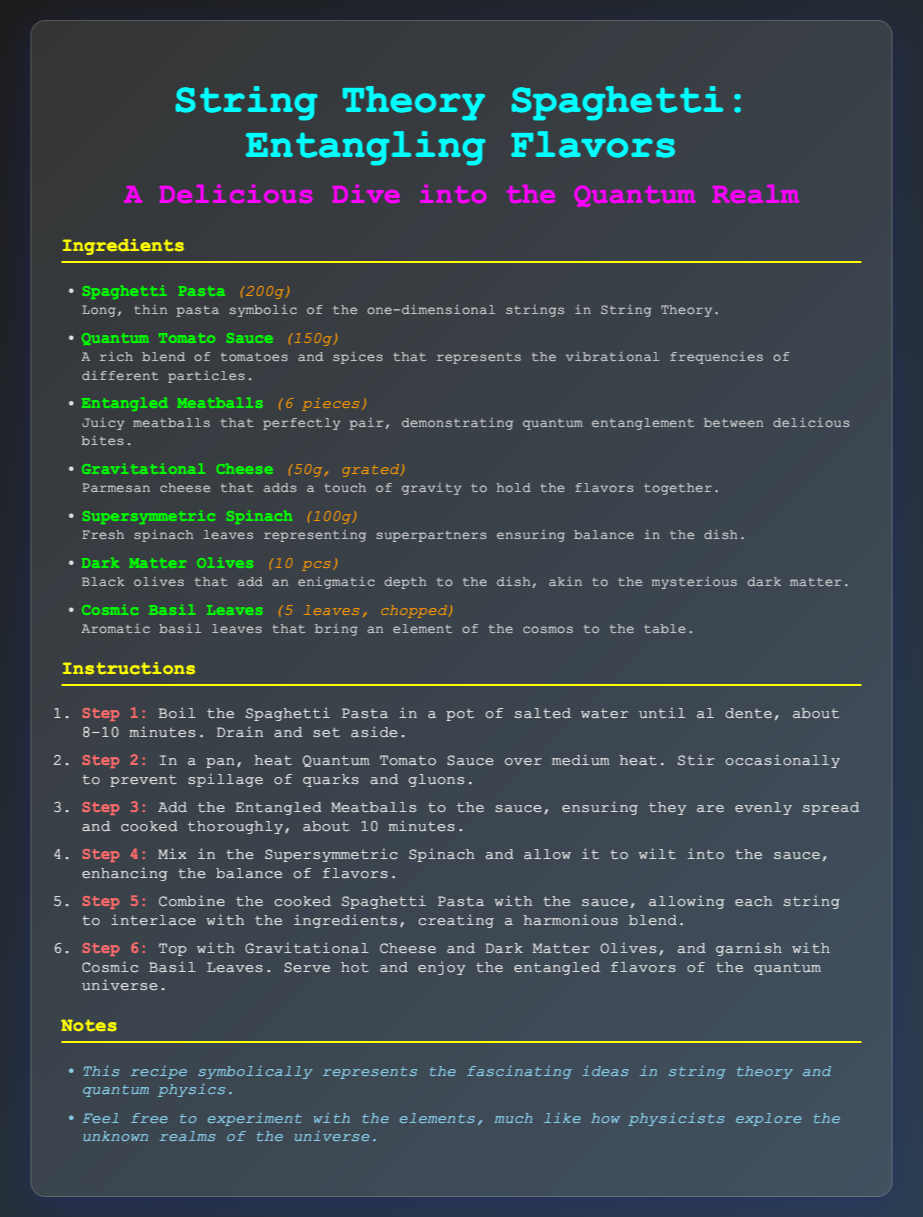What is the title of the recipe? The title of the recipe is prominently displayed at the top of the document.
Answer: String Theory Spaghetti: Entangling Flavors How much Spaghetti Pasta is needed? The quantity of Spaghetti Pasta is listed in the ingredients section.
Answer: 200g What represents the vibrational frequencies of different particles? This is described in the context of the ingredients, specifically relating to the sauce.
Answer: Quantum Tomato Sauce How many Entangled Meatballs are required? The number of meatballs is specified in the ingredients list.
Answer: 6 pieces What flavoring represents the mysterious dark matter? The ingredient associated with dark matter is mentioned in the document.
Answer: Dark Matter Olives Which ingredient is described as fresh and ensures balance? The ingredient that balances other flavors is identified in the document.
Answer: Supersymmetric Spinach In which step is the cheese added? The step in which cheese is topped onto the dish is stated in the preparation instructions.
Answer: Step 6 What is the cooking time for the pasta? The document specifies the duration for boiling pasta in the instructions.
Answer: 8-10 minutes What concept does the recipe symbolically represent? The overall theme of the recipe is indicated in the notes section.
Answer: String theory and quantum physics 